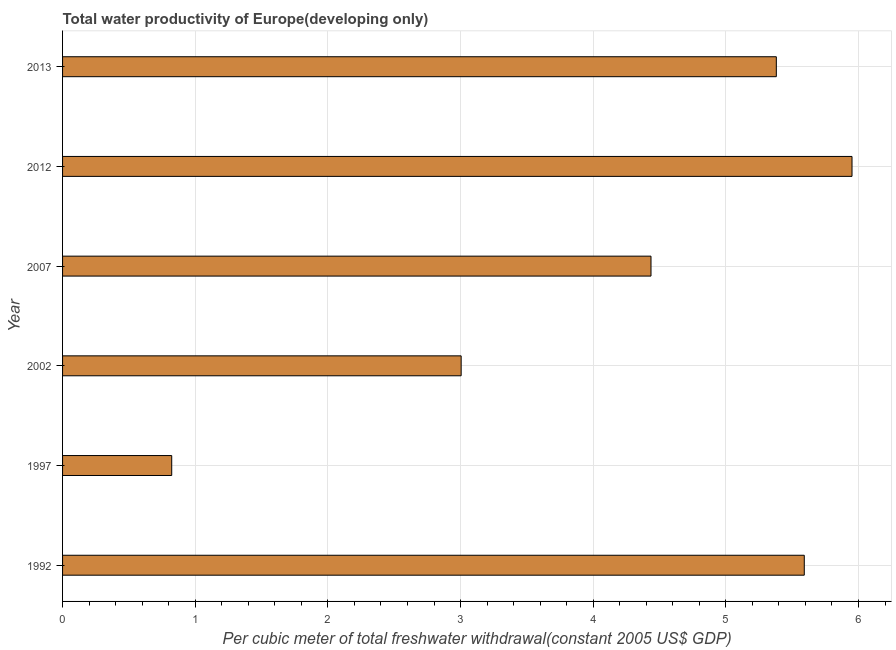What is the title of the graph?
Your answer should be very brief. Total water productivity of Europe(developing only). What is the label or title of the X-axis?
Ensure brevity in your answer.  Per cubic meter of total freshwater withdrawal(constant 2005 US$ GDP). What is the label or title of the Y-axis?
Your answer should be compact. Year. What is the total water productivity in 1997?
Offer a very short reply. 0.82. Across all years, what is the maximum total water productivity?
Your response must be concise. 5.95. Across all years, what is the minimum total water productivity?
Offer a very short reply. 0.82. What is the sum of the total water productivity?
Offer a very short reply. 25.19. What is the difference between the total water productivity in 1997 and 2002?
Offer a terse response. -2.18. What is the average total water productivity per year?
Make the answer very short. 4.2. What is the median total water productivity?
Give a very brief answer. 4.91. What is the ratio of the total water productivity in 1997 to that in 2002?
Provide a short and direct response. 0.27. Is the difference between the total water productivity in 1992 and 2007 greater than the difference between any two years?
Offer a very short reply. No. What is the difference between the highest and the second highest total water productivity?
Keep it short and to the point. 0.36. What is the difference between the highest and the lowest total water productivity?
Offer a very short reply. 5.13. How many bars are there?
Provide a succinct answer. 6. Are all the bars in the graph horizontal?
Offer a very short reply. Yes. How many years are there in the graph?
Make the answer very short. 6. What is the difference between two consecutive major ticks on the X-axis?
Your response must be concise. 1. Are the values on the major ticks of X-axis written in scientific E-notation?
Give a very brief answer. No. What is the Per cubic meter of total freshwater withdrawal(constant 2005 US$ GDP) of 1992?
Offer a very short reply. 5.59. What is the Per cubic meter of total freshwater withdrawal(constant 2005 US$ GDP) in 1997?
Make the answer very short. 0.82. What is the Per cubic meter of total freshwater withdrawal(constant 2005 US$ GDP) in 2002?
Your answer should be compact. 3. What is the Per cubic meter of total freshwater withdrawal(constant 2005 US$ GDP) in 2007?
Ensure brevity in your answer.  4.44. What is the Per cubic meter of total freshwater withdrawal(constant 2005 US$ GDP) in 2012?
Provide a succinct answer. 5.95. What is the Per cubic meter of total freshwater withdrawal(constant 2005 US$ GDP) in 2013?
Keep it short and to the point. 5.38. What is the difference between the Per cubic meter of total freshwater withdrawal(constant 2005 US$ GDP) in 1992 and 1997?
Your answer should be very brief. 4.77. What is the difference between the Per cubic meter of total freshwater withdrawal(constant 2005 US$ GDP) in 1992 and 2002?
Keep it short and to the point. 2.59. What is the difference between the Per cubic meter of total freshwater withdrawal(constant 2005 US$ GDP) in 1992 and 2007?
Give a very brief answer. 1.16. What is the difference between the Per cubic meter of total freshwater withdrawal(constant 2005 US$ GDP) in 1992 and 2012?
Your response must be concise. -0.36. What is the difference between the Per cubic meter of total freshwater withdrawal(constant 2005 US$ GDP) in 1992 and 2013?
Your answer should be very brief. 0.21. What is the difference between the Per cubic meter of total freshwater withdrawal(constant 2005 US$ GDP) in 1997 and 2002?
Offer a terse response. -2.18. What is the difference between the Per cubic meter of total freshwater withdrawal(constant 2005 US$ GDP) in 1997 and 2007?
Make the answer very short. -3.61. What is the difference between the Per cubic meter of total freshwater withdrawal(constant 2005 US$ GDP) in 1997 and 2012?
Your answer should be compact. -5.13. What is the difference between the Per cubic meter of total freshwater withdrawal(constant 2005 US$ GDP) in 1997 and 2013?
Give a very brief answer. -4.56. What is the difference between the Per cubic meter of total freshwater withdrawal(constant 2005 US$ GDP) in 2002 and 2007?
Make the answer very short. -1.43. What is the difference between the Per cubic meter of total freshwater withdrawal(constant 2005 US$ GDP) in 2002 and 2012?
Provide a succinct answer. -2.95. What is the difference between the Per cubic meter of total freshwater withdrawal(constant 2005 US$ GDP) in 2002 and 2013?
Provide a succinct answer. -2.38. What is the difference between the Per cubic meter of total freshwater withdrawal(constant 2005 US$ GDP) in 2007 and 2012?
Your answer should be very brief. -1.52. What is the difference between the Per cubic meter of total freshwater withdrawal(constant 2005 US$ GDP) in 2007 and 2013?
Keep it short and to the point. -0.94. What is the difference between the Per cubic meter of total freshwater withdrawal(constant 2005 US$ GDP) in 2012 and 2013?
Provide a succinct answer. 0.57. What is the ratio of the Per cubic meter of total freshwater withdrawal(constant 2005 US$ GDP) in 1992 to that in 1997?
Ensure brevity in your answer.  6.79. What is the ratio of the Per cubic meter of total freshwater withdrawal(constant 2005 US$ GDP) in 1992 to that in 2002?
Offer a very short reply. 1.86. What is the ratio of the Per cubic meter of total freshwater withdrawal(constant 2005 US$ GDP) in 1992 to that in 2007?
Give a very brief answer. 1.26. What is the ratio of the Per cubic meter of total freshwater withdrawal(constant 2005 US$ GDP) in 1992 to that in 2012?
Keep it short and to the point. 0.94. What is the ratio of the Per cubic meter of total freshwater withdrawal(constant 2005 US$ GDP) in 1992 to that in 2013?
Your response must be concise. 1.04. What is the ratio of the Per cubic meter of total freshwater withdrawal(constant 2005 US$ GDP) in 1997 to that in 2002?
Provide a short and direct response. 0.27. What is the ratio of the Per cubic meter of total freshwater withdrawal(constant 2005 US$ GDP) in 1997 to that in 2007?
Offer a very short reply. 0.19. What is the ratio of the Per cubic meter of total freshwater withdrawal(constant 2005 US$ GDP) in 1997 to that in 2012?
Make the answer very short. 0.14. What is the ratio of the Per cubic meter of total freshwater withdrawal(constant 2005 US$ GDP) in 1997 to that in 2013?
Offer a terse response. 0.15. What is the ratio of the Per cubic meter of total freshwater withdrawal(constant 2005 US$ GDP) in 2002 to that in 2007?
Provide a succinct answer. 0.68. What is the ratio of the Per cubic meter of total freshwater withdrawal(constant 2005 US$ GDP) in 2002 to that in 2012?
Your answer should be very brief. 0.51. What is the ratio of the Per cubic meter of total freshwater withdrawal(constant 2005 US$ GDP) in 2002 to that in 2013?
Provide a succinct answer. 0.56. What is the ratio of the Per cubic meter of total freshwater withdrawal(constant 2005 US$ GDP) in 2007 to that in 2012?
Give a very brief answer. 0.74. What is the ratio of the Per cubic meter of total freshwater withdrawal(constant 2005 US$ GDP) in 2007 to that in 2013?
Give a very brief answer. 0.82. What is the ratio of the Per cubic meter of total freshwater withdrawal(constant 2005 US$ GDP) in 2012 to that in 2013?
Provide a succinct answer. 1.11. 